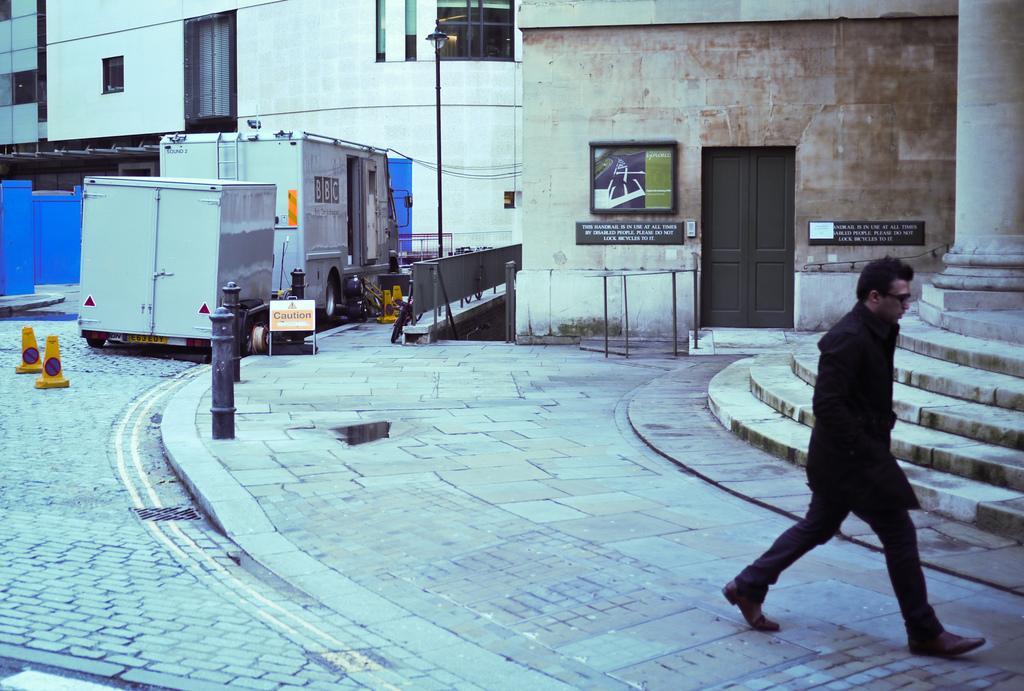Can you describe this image briefly? On the right side of the image, we can see a person is walking on the footpath. Here we can see stairs, pillar. Background we can see buildings, house, door, vehicles, poles, board, traffic cones, light, name boards, glass windows. 